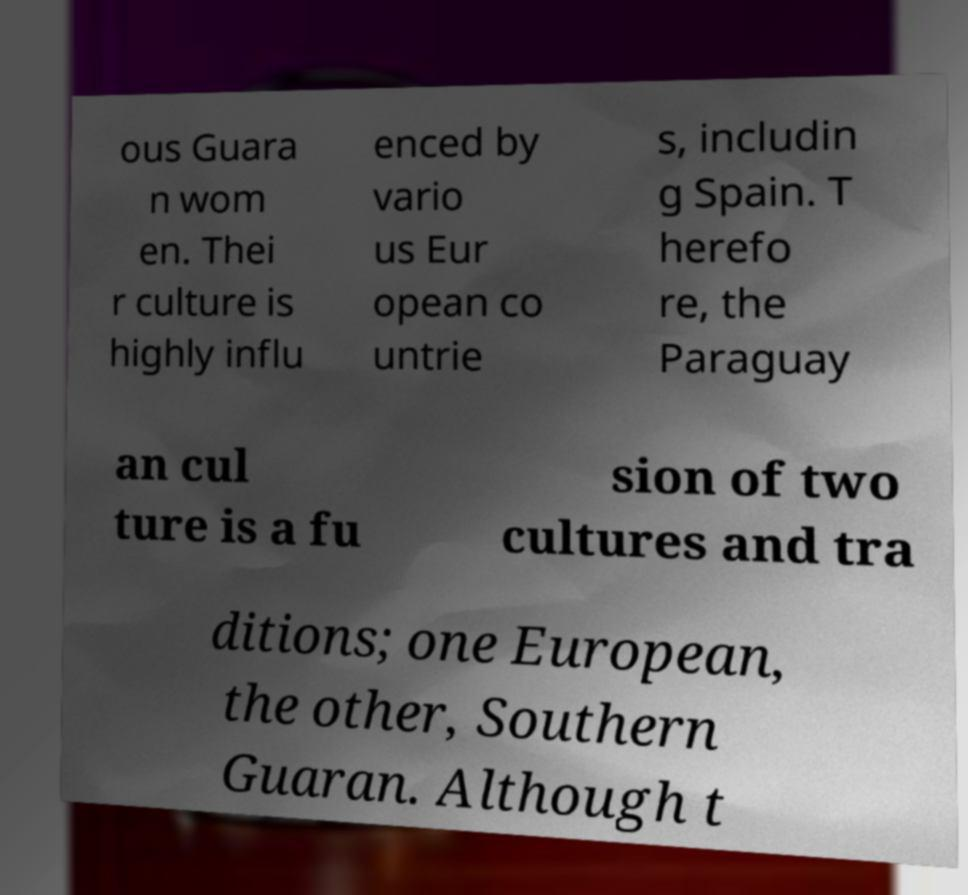Please read and relay the text visible in this image. What does it say? ous Guara n wom en. Thei r culture is highly influ enced by vario us Eur opean co untrie s, includin g Spain. T herefo re, the Paraguay an cul ture is a fu sion of two cultures and tra ditions; one European, the other, Southern Guaran. Although t 